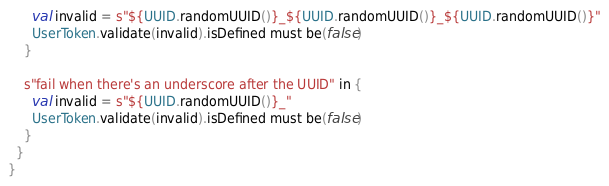<code> <loc_0><loc_0><loc_500><loc_500><_Scala_>      val invalid = s"${UUID.randomUUID()}_${UUID.randomUUID()}_${UUID.randomUUID()}"
      UserToken.validate(invalid).isDefined must be(false)
    }

    s"fail when there's an underscore after the UUID" in {
      val invalid = s"${UUID.randomUUID()}_"
      UserToken.validate(invalid).isDefined must be(false)
    }
  }
}
</code> 